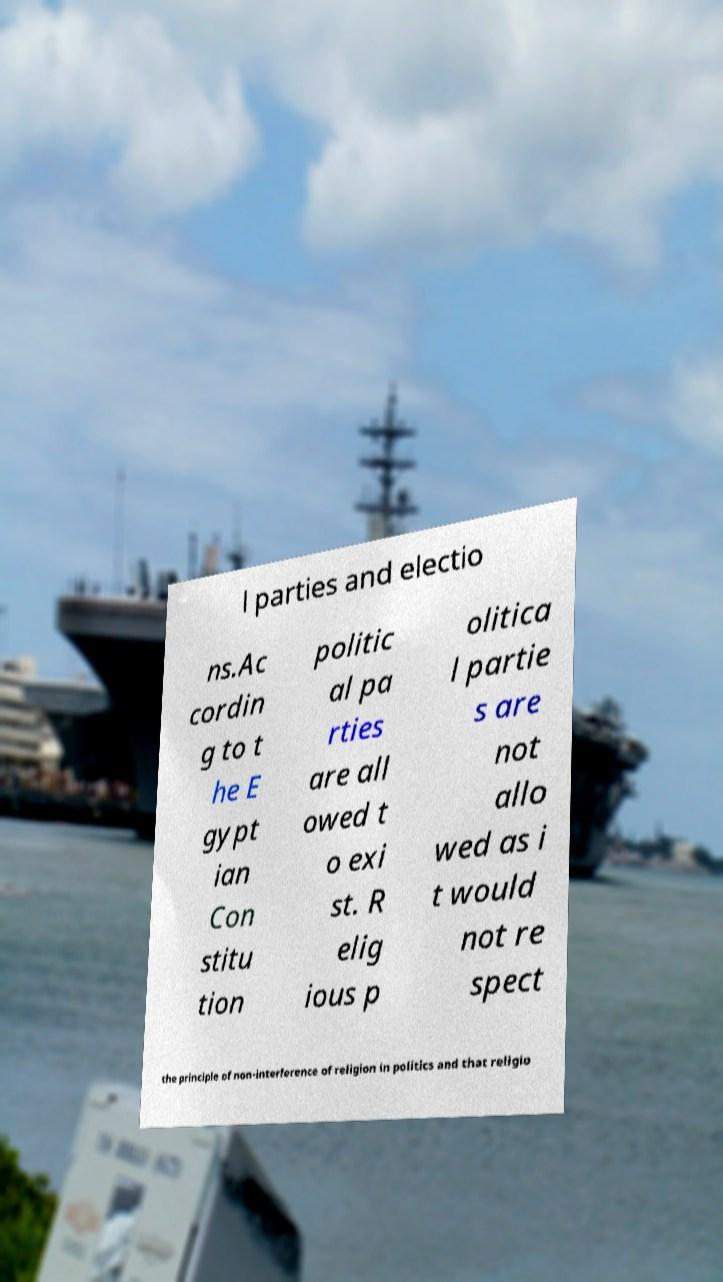What messages or text are displayed in this image? I need them in a readable, typed format. l parties and electio ns.Ac cordin g to t he E gypt ian Con stitu tion politic al pa rties are all owed t o exi st. R elig ious p olitica l partie s are not allo wed as i t would not re spect the principle of non-interference of religion in politics and that religio 